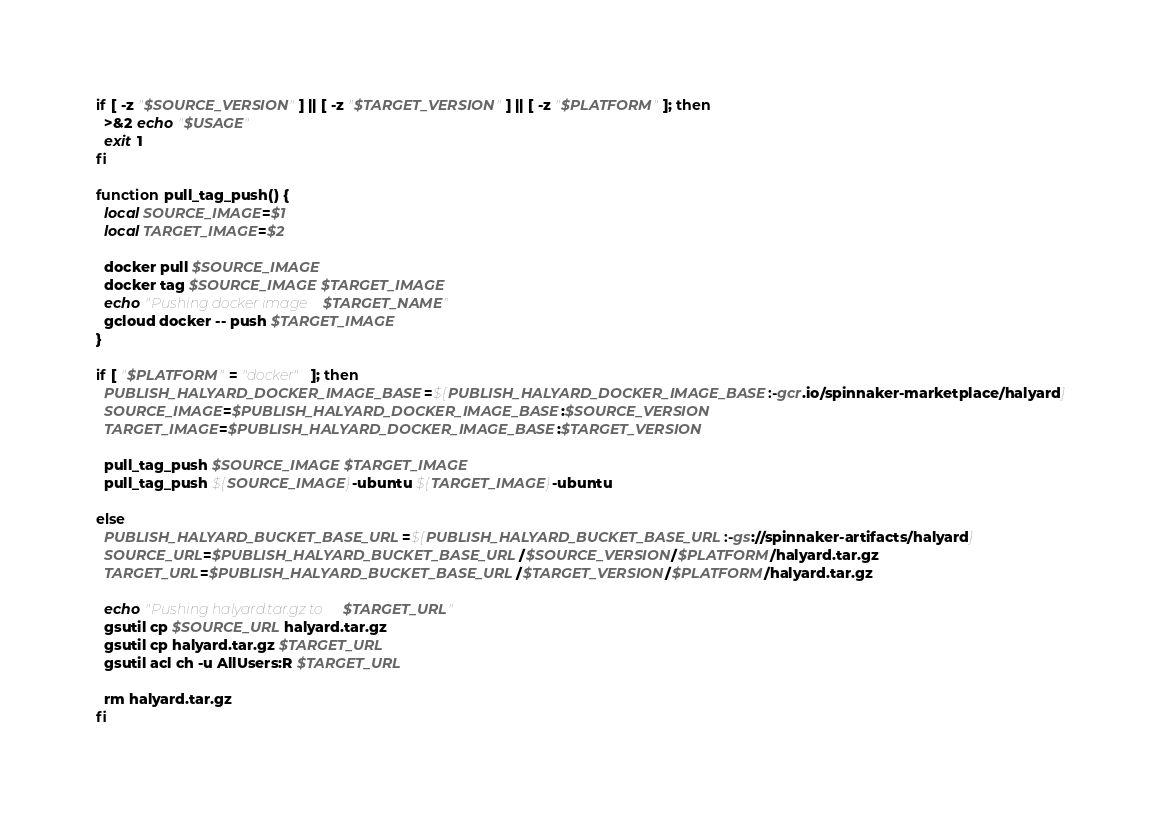Convert code to text. <code><loc_0><loc_0><loc_500><loc_500><_Bash_>if [ -z "$SOURCE_VERSION" ] || [ -z "$TARGET_VERSION" ] || [ -z "$PLATFORM" ]; then
  >&2 echo "$USAGE"
  exit 1
fi

function pull_tag_push() {
  local SOURCE_IMAGE=$1
  local TARGET_IMAGE=$2

  docker pull $SOURCE_IMAGE
  docker tag $SOURCE_IMAGE $TARGET_IMAGE
  echo "Pushing docker image $TARGET_NAME"
  gcloud docker -- push $TARGET_IMAGE
}

if [ "$PLATFORM" = "docker" ]; then
  PUBLISH_HALYARD_DOCKER_IMAGE_BASE=${PUBLISH_HALYARD_DOCKER_IMAGE_BASE:-gcr.io/spinnaker-marketplace/halyard}
  SOURCE_IMAGE=$PUBLISH_HALYARD_DOCKER_IMAGE_BASE:$SOURCE_VERSION
  TARGET_IMAGE=$PUBLISH_HALYARD_DOCKER_IMAGE_BASE:$TARGET_VERSION

  pull_tag_push $SOURCE_IMAGE $TARGET_IMAGE
  pull_tag_push ${SOURCE_IMAGE}-ubuntu ${TARGET_IMAGE}-ubuntu

else 
  PUBLISH_HALYARD_BUCKET_BASE_URL=${PUBLISH_HALYARD_BUCKET_BASE_URL:-gs://spinnaker-artifacts/halyard}
  SOURCE_URL=$PUBLISH_HALYARD_BUCKET_BASE_URL/$SOURCE_VERSION/$PLATFORM/halyard.tar.gz
  TARGET_URL=$PUBLISH_HALYARD_BUCKET_BASE_URL/$TARGET_VERSION/$PLATFORM/halyard.tar.gz

  echo "Pushing halyard.tar.gz to $TARGET_URL"
  gsutil cp $SOURCE_URL halyard.tar.gz
  gsutil cp halyard.tar.gz $TARGET_URL
  gsutil acl ch -u AllUsers:R $TARGET_URL

  rm halyard.tar.gz
fi
</code> 